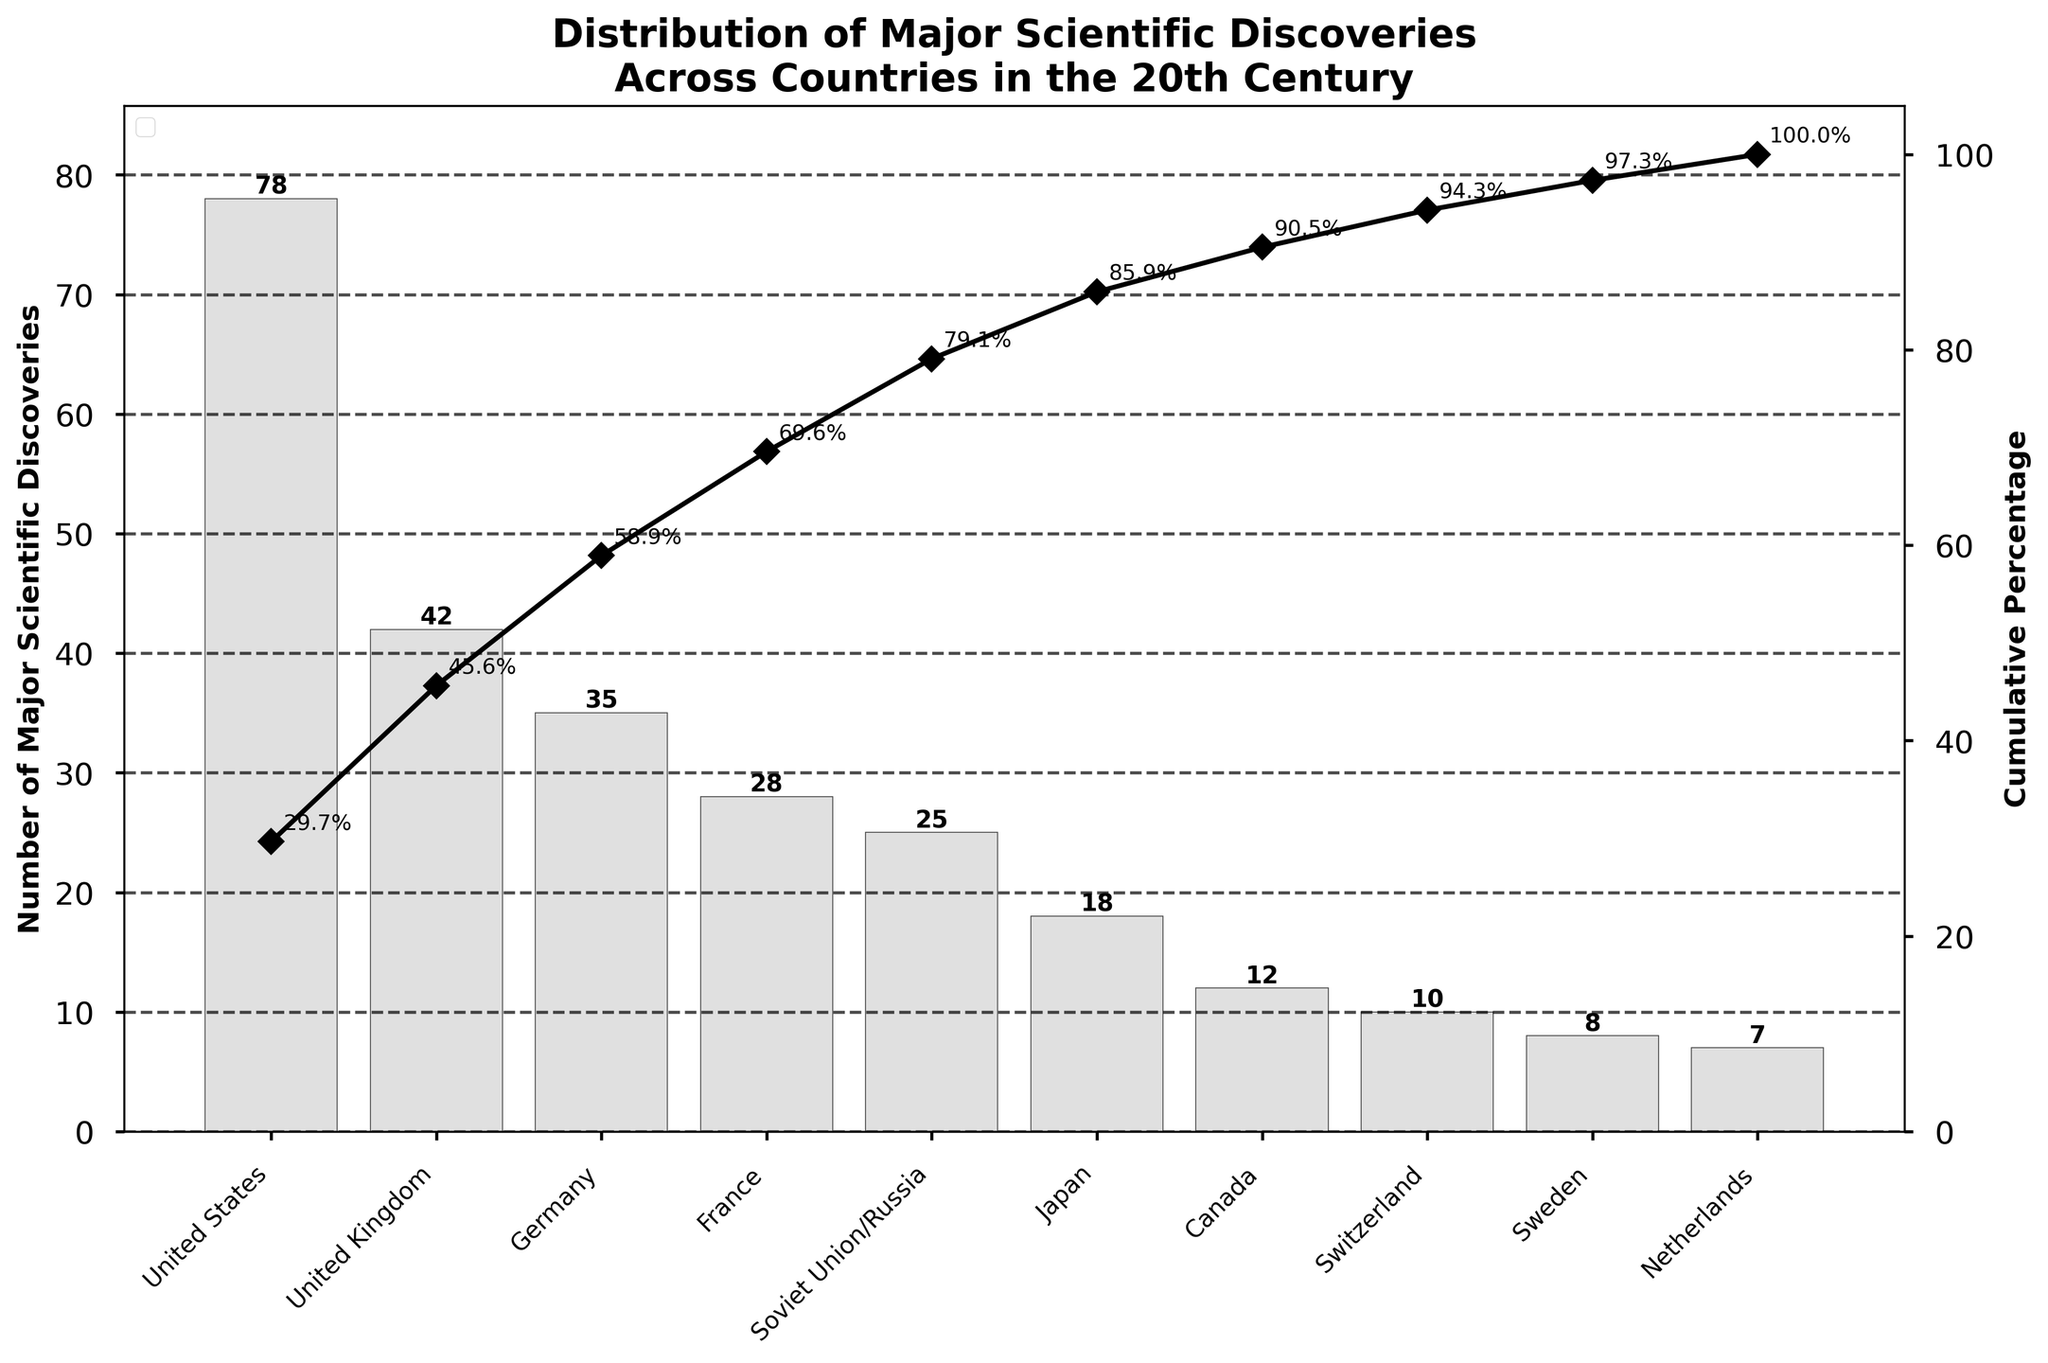what’s the title of the figure? The figure has a visible title at the top that reads “Distribution of Major Scientific Discoveries Across Countries in the 20th Century”.
Answer: Distribution of Major Scientific Discoveries Across Countries in the 20th Century What is the total number of major scientific discoveries made by the top three countries combined? To find the total number of major scientific discoveries made by the top three countries, look at the bar values for United States (78), United Kingdom (42), and Germany (35). Summing up these values: 78 + 42 + 35 = 155.
Answer: 155 What percentage of the total discoveries were made by the United States alone? The total number of discoveries is the sum of all the discoveries listed on the bars. Calculating the total (78 + 42 + 35 + 28 + 25 + 18 + 12 + 10 + 8 + 7 = 263). The number of discoveries made by the United States is 78. Then, calculate the percentage: (78 / 263) * 100 ≈ 29.7%.
Answer: 29.7% Which country has the lowest number of major scientific discoveries, and how many did they have? The bar with the shortest height and the smallest number indicates the country with the lowest number of discoveries, which is the Netherlands with 7 discoveries.
Answer: Netherlands, 7 Between which two countries is the biggest difference in the number of discoveries, and what is that difference? By inspecting the chart, the largest difference is between the United States (78) and United Kingdom (42). Calculating the difference: 78 - 42 = 36.
Answer: United States and United Kingdom, 36 How many countries made fewer than 20 major scientific discoveries? Counting the bars with values less than 20: Canada (12), Switzerland (10), Sweden (8), and Netherlands (7). There are four countries in total.
Answer: 4 What is the cumulative percentage of discoveries after the sixth country in the list joined, and which country is it? The sixth country in the list is Japan with 18 discoveries. The cumulative percentage can be checked from the cumulative line plot: it is about 88.6%.
Answer: Japan, 88.6% How many more discoveries did France make compared to Japan? France made 28 discoveries and Japan made 18. Subtracting Japan’s number from France’s number: 28 - 18 = 10.
Answer: 10 What is the cumulative percentage shown on the graph for Germany? The cumulative percentage for Germany, displayed on the graph near the corresponding data point, is about 59.3%.
Answer: 59.3% What is the average number of major scientific discoveries made by the countries listed? To find the average, sum the total number of discoveries (263) and divide by the number of countries listed (10): 263 / 10 = 26.3.
Answer: 26.3 